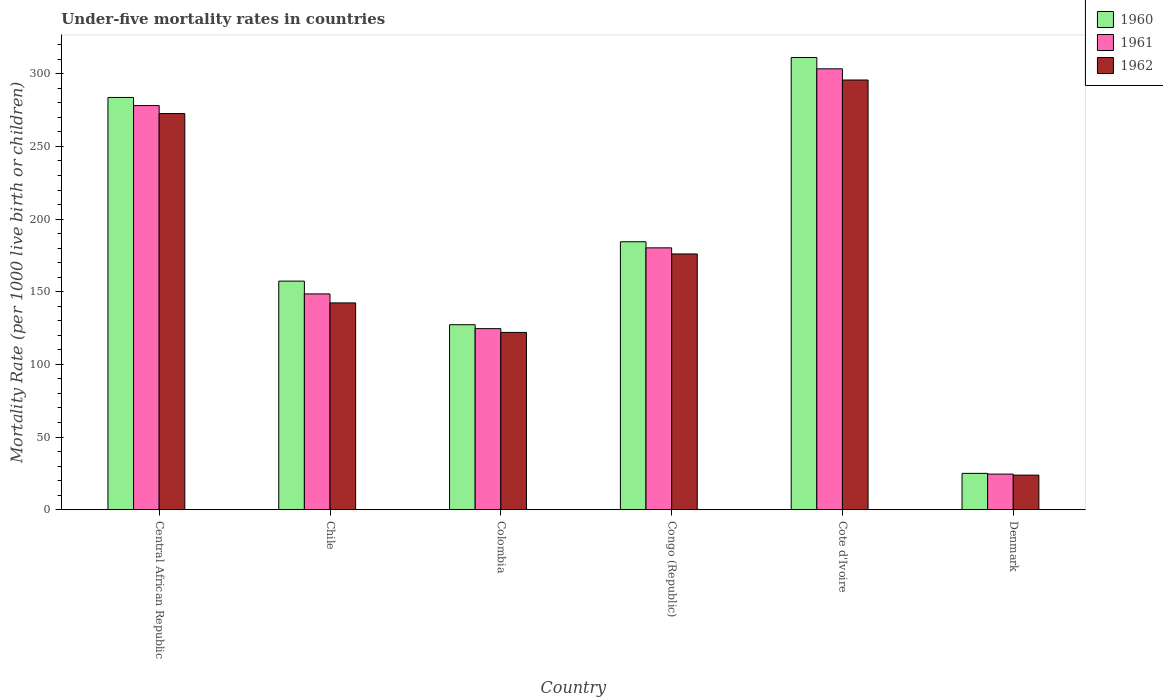How many different coloured bars are there?
Give a very brief answer. 3. How many groups of bars are there?
Your answer should be very brief. 6. Are the number of bars per tick equal to the number of legend labels?
Make the answer very short. Yes. Are the number of bars on each tick of the X-axis equal?
Give a very brief answer. Yes. How many bars are there on the 5th tick from the left?
Provide a succinct answer. 3. How many bars are there on the 6th tick from the right?
Provide a short and direct response. 3. What is the label of the 1st group of bars from the left?
Your answer should be compact. Central African Republic. In how many cases, is the number of bars for a given country not equal to the number of legend labels?
Make the answer very short. 0. What is the under-five mortality rate in 1960 in Central African Republic?
Make the answer very short. 283.7. Across all countries, what is the maximum under-five mortality rate in 1962?
Offer a terse response. 295.7. Across all countries, what is the minimum under-five mortality rate in 1961?
Make the answer very short. 24.5. In which country was the under-five mortality rate in 1961 maximum?
Provide a succinct answer. Cote d'Ivoire. What is the total under-five mortality rate in 1961 in the graph?
Your response must be concise. 1059.3. What is the difference between the under-five mortality rate in 1962 in Chile and that in Denmark?
Keep it short and to the point. 118.5. What is the difference between the under-five mortality rate in 1962 in Colombia and the under-five mortality rate in 1961 in Congo (Republic)?
Keep it short and to the point. -58.2. What is the average under-five mortality rate in 1962 per country?
Ensure brevity in your answer.  172.07. What is the difference between the under-five mortality rate of/in 1961 and under-five mortality rate of/in 1960 in Colombia?
Keep it short and to the point. -2.7. What is the ratio of the under-five mortality rate in 1962 in Chile to that in Congo (Republic)?
Provide a short and direct response. 0.81. Is the under-five mortality rate in 1962 in Chile less than that in Colombia?
Provide a succinct answer. No. Is the difference between the under-five mortality rate in 1961 in Cote d'Ivoire and Denmark greater than the difference between the under-five mortality rate in 1960 in Cote d'Ivoire and Denmark?
Your answer should be very brief. No. What is the difference between the highest and the second highest under-five mortality rate in 1961?
Keep it short and to the point. -97.9. What is the difference between the highest and the lowest under-five mortality rate in 1960?
Keep it short and to the point. 286.2. In how many countries, is the under-five mortality rate in 1960 greater than the average under-five mortality rate in 1960 taken over all countries?
Give a very brief answer. 3. Is the sum of the under-five mortality rate in 1961 in Colombia and Congo (Republic) greater than the maximum under-five mortality rate in 1962 across all countries?
Your answer should be compact. Yes. How many bars are there?
Your response must be concise. 18. How many countries are there in the graph?
Offer a very short reply. 6. Does the graph contain any zero values?
Provide a succinct answer. No. Does the graph contain grids?
Make the answer very short. No. How many legend labels are there?
Provide a short and direct response. 3. How are the legend labels stacked?
Make the answer very short. Vertical. What is the title of the graph?
Provide a succinct answer. Under-five mortality rates in countries. What is the label or title of the Y-axis?
Your response must be concise. Mortality Rate (per 1000 live birth or children). What is the Mortality Rate (per 1000 live birth or children) of 1960 in Central African Republic?
Offer a terse response. 283.7. What is the Mortality Rate (per 1000 live birth or children) in 1961 in Central African Republic?
Make the answer very short. 278.1. What is the Mortality Rate (per 1000 live birth or children) of 1962 in Central African Republic?
Offer a very short reply. 272.6. What is the Mortality Rate (per 1000 live birth or children) in 1960 in Chile?
Your response must be concise. 157.3. What is the Mortality Rate (per 1000 live birth or children) in 1961 in Chile?
Keep it short and to the point. 148.5. What is the Mortality Rate (per 1000 live birth or children) of 1962 in Chile?
Offer a terse response. 142.3. What is the Mortality Rate (per 1000 live birth or children) in 1960 in Colombia?
Provide a short and direct response. 127.3. What is the Mortality Rate (per 1000 live birth or children) of 1961 in Colombia?
Provide a short and direct response. 124.6. What is the Mortality Rate (per 1000 live birth or children) of 1962 in Colombia?
Your answer should be compact. 122. What is the Mortality Rate (per 1000 live birth or children) in 1960 in Congo (Republic)?
Make the answer very short. 184.4. What is the Mortality Rate (per 1000 live birth or children) of 1961 in Congo (Republic)?
Offer a terse response. 180.2. What is the Mortality Rate (per 1000 live birth or children) of 1962 in Congo (Republic)?
Keep it short and to the point. 176. What is the Mortality Rate (per 1000 live birth or children) in 1960 in Cote d'Ivoire?
Offer a terse response. 311.2. What is the Mortality Rate (per 1000 live birth or children) in 1961 in Cote d'Ivoire?
Your response must be concise. 303.4. What is the Mortality Rate (per 1000 live birth or children) of 1962 in Cote d'Ivoire?
Provide a short and direct response. 295.7. What is the Mortality Rate (per 1000 live birth or children) of 1962 in Denmark?
Offer a very short reply. 23.8. Across all countries, what is the maximum Mortality Rate (per 1000 live birth or children) in 1960?
Your answer should be compact. 311.2. Across all countries, what is the maximum Mortality Rate (per 1000 live birth or children) of 1961?
Keep it short and to the point. 303.4. Across all countries, what is the maximum Mortality Rate (per 1000 live birth or children) of 1962?
Your answer should be compact. 295.7. Across all countries, what is the minimum Mortality Rate (per 1000 live birth or children) of 1961?
Make the answer very short. 24.5. Across all countries, what is the minimum Mortality Rate (per 1000 live birth or children) in 1962?
Offer a terse response. 23.8. What is the total Mortality Rate (per 1000 live birth or children) in 1960 in the graph?
Offer a terse response. 1088.9. What is the total Mortality Rate (per 1000 live birth or children) of 1961 in the graph?
Make the answer very short. 1059.3. What is the total Mortality Rate (per 1000 live birth or children) of 1962 in the graph?
Keep it short and to the point. 1032.4. What is the difference between the Mortality Rate (per 1000 live birth or children) of 1960 in Central African Republic and that in Chile?
Offer a very short reply. 126.4. What is the difference between the Mortality Rate (per 1000 live birth or children) in 1961 in Central African Republic and that in Chile?
Give a very brief answer. 129.6. What is the difference between the Mortality Rate (per 1000 live birth or children) of 1962 in Central African Republic and that in Chile?
Give a very brief answer. 130.3. What is the difference between the Mortality Rate (per 1000 live birth or children) in 1960 in Central African Republic and that in Colombia?
Provide a short and direct response. 156.4. What is the difference between the Mortality Rate (per 1000 live birth or children) of 1961 in Central African Republic and that in Colombia?
Keep it short and to the point. 153.5. What is the difference between the Mortality Rate (per 1000 live birth or children) in 1962 in Central African Republic and that in Colombia?
Your answer should be very brief. 150.6. What is the difference between the Mortality Rate (per 1000 live birth or children) in 1960 in Central African Republic and that in Congo (Republic)?
Provide a succinct answer. 99.3. What is the difference between the Mortality Rate (per 1000 live birth or children) of 1961 in Central African Republic and that in Congo (Republic)?
Ensure brevity in your answer.  97.9. What is the difference between the Mortality Rate (per 1000 live birth or children) in 1962 in Central African Republic and that in Congo (Republic)?
Your response must be concise. 96.6. What is the difference between the Mortality Rate (per 1000 live birth or children) of 1960 in Central African Republic and that in Cote d'Ivoire?
Provide a short and direct response. -27.5. What is the difference between the Mortality Rate (per 1000 live birth or children) in 1961 in Central African Republic and that in Cote d'Ivoire?
Offer a very short reply. -25.3. What is the difference between the Mortality Rate (per 1000 live birth or children) in 1962 in Central African Republic and that in Cote d'Ivoire?
Provide a succinct answer. -23.1. What is the difference between the Mortality Rate (per 1000 live birth or children) in 1960 in Central African Republic and that in Denmark?
Offer a very short reply. 258.7. What is the difference between the Mortality Rate (per 1000 live birth or children) of 1961 in Central African Republic and that in Denmark?
Provide a short and direct response. 253.6. What is the difference between the Mortality Rate (per 1000 live birth or children) of 1962 in Central African Republic and that in Denmark?
Keep it short and to the point. 248.8. What is the difference between the Mortality Rate (per 1000 live birth or children) in 1961 in Chile and that in Colombia?
Your answer should be very brief. 23.9. What is the difference between the Mortality Rate (per 1000 live birth or children) in 1962 in Chile and that in Colombia?
Ensure brevity in your answer.  20.3. What is the difference between the Mortality Rate (per 1000 live birth or children) in 1960 in Chile and that in Congo (Republic)?
Your answer should be very brief. -27.1. What is the difference between the Mortality Rate (per 1000 live birth or children) in 1961 in Chile and that in Congo (Republic)?
Ensure brevity in your answer.  -31.7. What is the difference between the Mortality Rate (per 1000 live birth or children) in 1962 in Chile and that in Congo (Republic)?
Make the answer very short. -33.7. What is the difference between the Mortality Rate (per 1000 live birth or children) in 1960 in Chile and that in Cote d'Ivoire?
Your response must be concise. -153.9. What is the difference between the Mortality Rate (per 1000 live birth or children) in 1961 in Chile and that in Cote d'Ivoire?
Keep it short and to the point. -154.9. What is the difference between the Mortality Rate (per 1000 live birth or children) of 1962 in Chile and that in Cote d'Ivoire?
Your answer should be compact. -153.4. What is the difference between the Mortality Rate (per 1000 live birth or children) of 1960 in Chile and that in Denmark?
Provide a short and direct response. 132.3. What is the difference between the Mortality Rate (per 1000 live birth or children) of 1961 in Chile and that in Denmark?
Your response must be concise. 124. What is the difference between the Mortality Rate (per 1000 live birth or children) of 1962 in Chile and that in Denmark?
Your response must be concise. 118.5. What is the difference between the Mortality Rate (per 1000 live birth or children) in 1960 in Colombia and that in Congo (Republic)?
Keep it short and to the point. -57.1. What is the difference between the Mortality Rate (per 1000 live birth or children) of 1961 in Colombia and that in Congo (Republic)?
Keep it short and to the point. -55.6. What is the difference between the Mortality Rate (per 1000 live birth or children) of 1962 in Colombia and that in Congo (Republic)?
Make the answer very short. -54. What is the difference between the Mortality Rate (per 1000 live birth or children) in 1960 in Colombia and that in Cote d'Ivoire?
Offer a terse response. -183.9. What is the difference between the Mortality Rate (per 1000 live birth or children) in 1961 in Colombia and that in Cote d'Ivoire?
Make the answer very short. -178.8. What is the difference between the Mortality Rate (per 1000 live birth or children) of 1962 in Colombia and that in Cote d'Ivoire?
Offer a very short reply. -173.7. What is the difference between the Mortality Rate (per 1000 live birth or children) of 1960 in Colombia and that in Denmark?
Give a very brief answer. 102.3. What is the difference between the Mortality Rate (per 1000 live birth or children) of 1961 in Colombia and that in Denmark?
Provide a succinct answer. 100.1. What is the difference between the Mortality Rate (per 1000 live birth or children) in 1962 in Colombia and that in Denmark?
Offer a very short reply. 98.2. What is the difference between the Mortality Rate (per 1000 live birth or children) of 1960 in Congo (Republic) and that in Cote d'Ivoire?
Offer a terse response. -126.8. What is the difference between the Mortality Rate (per 1000 live birth or children) of 1961 in Congo (Republic) and that in Cote d'Ivoire?
Your answer should be compact. -123.2. What is the difference between the Mortality Rate (per 1000 live birth or children) of 1962 in Congo (Republic) and that in Cote d'Ivoire?
Your response must be concise. -119.7. What is the difference between the Mortality Rate (per 1000 live birth or children) of 1960 in Congo (Republic) and that in Denmark?
Your response must be concise. 159.4. What is the difference between the Mortality Rate (per 1000 live birth or children) in 1961 in Congo (Republic) and that in Denmark?
Offer a very short reply. 155.7. What is the difference between the Mortality Rate (per 1000 live birth or children) in 1962 in Congo (Republic) and that in Denmark?
Your answer should be compact. 152.2. What is the difference between the Mortality Rate (per 1000 live birth or children) of 1960 in Cote d'Ivoire and that in Denmark?
Provide a short and direct response. 286.2. What is the difference between the Mortality Rate (per 1000 live birth or children) of 1961 in Cote d'Ivoire and that in Denmark?
Ensure brevity in your answer.  278.9. What is the difference between the Mortality Rate (per 1000 live birth or children) in 1962 in Cote d'Ivoire and that in Denmark?
Ensure brevity in your answer.  271.9. What is the difference between the Mortality Rate (per 1000 live birth or children) of 1960 in Central African Republic and the Mortality Rate (per 1000 live birth or children) of 1961 in Chile?
Give a very brief answer. 135.2. What is the difference between the Mortality Rate (per 1000 live birth or children) in 1960 in Central African Republic and the Mortality Rate (per 1000 live birth or children) in 1962 in Chile?
Your answer should be compact. 141.4. What is the difference between the Mortality Rate (per 1000 live birth or children) in 1961 in Central African Republic and the Mortality Rate (per 1000 live birth or children) in 1962 in Chile?
Make the answer very short. 135.8. What is the difference between the Mortality Rate (per 1000 live birth or children) in 1960 in Central African Republic and the Mortality Rate (per 1000 live birth or children) in 1961 in Colombia?
Keep it short and to the point. 159.1. What is the difference between the Mortality Rate (per 1000 live birth or children) in 1960 in Central African Republic and the Mortality Rate (per 1000 live birth or children) in 1962 in Colombia?
Offer a terse response. 161.7. What is the difference between the Mortality Rate (per 1000 live birth or children) in 1961 in Central African Republic and the Mortality Rate (per 1000 live birth or children) in 1962 in Colombia?
Provide a short and direct response. 156.1. What is the difference between the Mortality Rate (per 1000 live birth or children) in 1960 in Central African Republic and the Mortality Rate (per 1000 live birth or children) in 1961 in Congo (Republic)?
Provide a succinct answer. 103.5. What is the difference between the Mortality Rate (per 1000 live birth or children) of 1960 in Central African Republic and the Mortality Rate (per 1000 live birth or children) of 1962 in Congo (Republic)?
Offer a very short reply. 107.7. What is the difference between the Mortality Rate (per 1000 live birth or children) in 1961 in Central African Republic and the Mortality Rate (per 1000 live birth or children) in 1962 in Congo (Republic)?
Your answer should be compact. 102.1. What is the difference between the Mortality Rate (per 1000 live birth or children) of 1960 in Central African Republic and the Mortality Rate (per 1000 live birth or children) of 1961 in Cote d'Ivoire?
Keep it short and to the point. -19.7. What is the difference between the Mortality Rate (per 1000 live birth or children) of 1961 in Central African Republic and the Mortality Rate (per 1000 live birth or children) of 1962 in Cote d'Ivoire?
Your answer should be very brief. -17.6. What is the difference between the Mortality Rate (per 1000 live birth or children) of 1960 in Central African Republic and the Mortality Rate (per 1000 live birth or children) of 1961 in Denmark?
Keep it short and to the point. 259.2. What is the difference between the Mortality Rate (per 1000 live birth or children) in 1960 in Central African Republic and the Mortality Rate (per 1000 live birth or children) in 1962 in Denmark?
Your answer should be compact. 259.9. What is the difference between the Mortality Rate (per 1000 live birth or children) of 1961 in Central African Republic and the Mortality Rate (per 1000 live birth or children) of 1962 in Denmark?
Ensure brevity in your answer.  254.3. What is the difference between the Mortality Rate (per 1000 live birth or children) of 1960 in Chile and the Mortality Rate (per 1000 live birth or children) of 1961 in Colombia?
Your answer should be very brief. 32.7. What is the difference between the Mortality Rate (per 1000 live birth or children) of 1960 in Chile and the Mortality Rate (per 1000 live birth or children) of 1962 in Colombia?
Offer a terse response. 35.3. What is the difference between the Mortality Rate (per 1000 live birth or children) in 1960 in Chile and the Mortality Rate (per 1000 live birth or children) in 1961 in Congo (Republic)?
Give a very brief answer. -22.9. What is the difference between the Mortality Rate (per 1000 live birth or children) in 1960 in Chile and the Mortality Rate (per 1000 live birth or children) in 1962 in Congo (Republic)?
Offer a terse response. -18.7. What is the difference between the Mortality Rate (per 1000 live birth or children) of 1961 in Chile and the Mortality Rate (per 1000 live birth or children) of 1962 in Congo (Republic)?
Offer a very short reply. -27.5. What is the difference between the Mortality Rate (per 1000 live birth or children) of 1960 in Chile and the Mortality Rate (per 1000 live birth or children) of 1961 in Cote d'Ivoire?
Give a very brief answer. -146.1. What is the difference between the Mortality Rate (per 1000 live birth or children) of 1960 in Chile and the Mortality Rate (per 1000 live birth or children) of 1962 in Cote d'Ivoire?
Offer a terse response. -138.4. What is the difference between the Mortality Rate (per 1000 live birth or children) of 1961 in Chile and the Mortality Rate (per 1000 live birth or children) of 1962 in Cote d'Ivoire?
Your answer should be very brief. -147.2. What is the difference between the Mortality Rate (per 1000 live birth or children) in 1960 in Chile and the Mortality Rate (per 1000 live birth or children) in 1961 in Denmark?
Your answer should be compact. 132.8. What is the difference between the Mortality Rate (per 1000 live birth or children) of 1960 in Chile and the Mortality Rate (per 1000 live birth or children) of 1962 in Denmark?
Ensure brevity in your answer.  133.5. What is the difference between the Mortality Rate (per 1000 live birth or children) of 1961 in Chile and the Mortality Rate (per 1000 live birth or children) of 1962 in Denmark?
Your response must be concise. 124.7. What is the difference between the Mortality Rate (per 1000 live birth or children) in 1960 in Colombia and the Mortality Rate (per 1000 live birth or children) in 1961 in Congo (Republic)?
Ensure brevity in your answer.  -52.9. What is the difference between the Mortality Rate (per 1000 live birth or children) in 1960 in Colombia and the Mortality Rate (per 1000 live birth or children) in 1962 in Congo (Republic)?
Provide a succinct answer. -48.7. What is the difference between the Mortality Rate (per 1000 live birth or children) in 1961 in Colombia and the Mortality Rate (per 1000 live birth or children) in 1962 in Congo (Republic)?
Your answer should be compact. -51.4. What is the difference between the Mortality Rate (per 1000 live birth or children) of 1960 in Colombia and the Mortality Rate (per 1000 live birth or children) of 1961 in Cote d'Ivoire?
Make the answer very short. -176.1. What is the difference between the Mortality Rate (per 1000 live birth or children) of 1960 in Colombia and the Mortality Rate (per 1000 live birth or children) of 1962 in Cote d'Ivoire?
Provide a succinct answer. -168.4. What is the difference between the Mortality Rate (per 1000 live birth or children) of 1961 in Colombia and the Mortality Rate (per 1000 live birth or children) of 1962 in Cote d'Ivoire?
Offer a terse response. -171.1. What is the difference between the Mortality Rate (per 1000 live birth or children) in 1960 in Colombia and the Mortality Rate (per 1000 live birth or children) in 1961 in Denmark?
Your response must be concise. 102.8. What is the difference between the Mortality Rate (per 1000 live birth or children) in 1960 in Colombia and the Mortality Rate (per 1000 live birth or children) in 1962 in Denmark?
Your response must be concise. 103.5. What is the difference between the Mortality Rate (per 1000 live birth or children) of 1961 in Colombia and the Mortality Rate (per 1000 live birth or children) of 1962 in Denmark?
Offer a very short reply. 100.8. What is the difference between the Mortality Rate (per 1000 live birth or children) of 1960 in Congo (Republic) and the Mortality Rate (per 1000 live birth or children) of 1961 in Cote d'Ivoire?
Provide a short and direct response. -119. What is the difference between the Mortality Rate (per 1000 live birth or children) of 1960 in Congo (Republic) and the Mortality Rate (per 1000 live birth or children) of 1962 in Cote d'Ivoire?
Your answer should be compact. -111.3. What is the difference between the Mortality Rate (per 1000 live birth or children) in 1961 in Congo (Republic) and the Mortality Rate (per 1000 live birth or children) in 1962 in Cote d'Ivoire?
Provide a short and direct response. -115.5. What is the difference between the Mortality Rate (per 1000 live birth or children) in 1960 in Congo (Republic) and the Mortality Rate (per 1000 live birth or children) in 1961 in Denmark?
Offer a very short reply. 159.9. What is the difference between the Mortality Rate (per 1000 live birth or children) in 1960 in Congo (Republic) and the Mortality Rate (per 1000 live birth or children) in 1962 in Denmark?
Provide a succinct answer. 160.6. What is the difference between the Mortality Rate (per 1000 live birth or children) of 1961 in Congo (Republic) and the Mortality Rate (per 1000 live birth or children) of 1962 in Denmark?
Ensure brevity in your answer.  156.4. What is the difference between the Mortality Rate (per 1000 live birth or children) in 1960 in Cote d'Ivoire and the Mortality Rate (per 1000 live birth or children) in 1961 in Denmark?
Offer a terse response. 286.7. What is the difference between the Mortality Rate (per 1000 live birth or children) of 1960 in Cote d'Ivoire and the Mortality Rate (per 1000 live birth or children) of 1962 in Denmark?
Keep it short and to the point. 287.4. What is the difference between the Mortality Rate (per 1000 live birth or children) of 1961 in Cote d'Ivoire and the Mortality Rate (per 1000 live birth or children) of 1962 in Denmark?
Give a very brief answer. 279.6. What is the average Mortality Rate (per 1000 live birth or children) of 1960 per country?
Offer a terse response. 181.48. What is the average Mortality Rate (per 1000 live birth or children) in 1961 per country?
Keep it short and to the point. 176.55. What is the average Mortality Rate (per 1000 live birth or children) in 1962 per country?
Provide a short and direct response. 172.07. What is the difference between the Mortality Rate (per 1000 live birth or children) of 1960 and Mortality Rate (per 1000 live birth or children) of 1961 in Central African Republic?
Ensure brevity in your answer.  5.6. What is the difference between the Mortality Rate (per 1000 live birth or children) in 1961 and Mortality Rate (per 1000 live birth or children) in 1962 in Central African Republic?
Provide a short and direct response. 5.5. What is the difference between the Mortality Rate (per 1000 live birth or children) in 1960 and Mortality Rate (per 1000 live birth or children) in 1962 in Chile?
Offer a very short reply. 15. What is the difference between the Mortality Rate (per 1000 live birth or children) in 1960 and Mortality Rate (per 1000 live birth or children) in 1962 in Colombia?
Give a very brief answer. 5.3. What is the difference between the Mortality Rate (per 1000 live birth or children) in 1960 and Mortality Rate (per 1000 live birth or children) in 1961 in Cote d'Ivoire?
Your answer should be compact. 7.8. What is the difference between the Mortality Rate (per 1000 live birth or children) of 1960 and Mortality Rate (per 1000 live birth or children) of 1961 in Denmark?
Offer a terse response. 0.5. What is the ratio of the Mortality Rate (per 1000 live birth or children) in 1960 in Central African Republic to that in Chile?
Offer a very short reply. 1.8. What is the ratio of the Mortality Rate (per 1000 live birth or children) in 1961 in Central African Republic to that in Chile?
Offer a very short reply. 1.87. What is the ratio of the Mortality Rate (per 1000 live birth or children) of 1962 in Central African Republic to that in Chile?
Your answer should be compact. 1.92. What is the ratio of the Mortality Rate (per 1000 live birth or children) of 1960 in Central African Republic to that in Colombia?
Your answer should be very brief. 2.23. What is the ratio of the Mortality Rate (per 1000 live birth or children) of 1961 in Central African Republic to that in Colombia?
Ensure brevity in your answer.  2.23. What is the ratio of the Mortality Rate (per 1000 live birth or children) in 1962 in Central African Republic to that in Colombia?
Ensure brevity in your answer.  2.23. What is the ratio of the Mortality Rate (per 1000 live birth or children) of 1960 in Central African Republic to that in Congo (Republic)?
Offer a very short reply. 1.54. What is the ratio of the Mortality Rate (per 1000 live birth or children) in 1961 in Central African Republic to that in Congo (Republic)?
Offer a terse response. 1.54. What is the ratio of the Mortality Rate (per 1000 live birth or children) of 1962 in Central African Republic to that in Congo (Republic)?
Keep it short and to the point. 1.55. What is the ratio of the Mortality Rate (per 1000 live birth or children) of 1960 in Central African Republic to that in Cote d'Ivoire?
Keep it short and to the point. 0.91. What is the ratio of the Mortality Rate (per 1000 live birth or children) in 1961 in Central African Republic to that in Cote d'Ivoire?
Your answer should be very brief. 0.92. What is the ratio of the Mortality Rate (per 1000 live birth or children) of 1962 in Central African Republic to that in Cote d'Ivoire?
Keep it short and to the point. 0.92. What is the ratio of the Mortality Rate (per 1000 live birth or children) of 1960 in Central African Republic to that in Denmark?
Your answer should be compact. 11.35. What is the ratio of the Mortality Rate (per 1000 live birth or children) of 1961 in Central African Republic to that in Denmark?
Provide a short and direct response. 11.35. What is the ratio of the Mortality Rate (per 1000 live birth or children) of 1962 in Central African Republic to that in Denmark?
Keep it short and to the point. 11.45. What is the ratio of the Mortality Rate (per 1000 live birth or children) of 1960 in Chile to that in Colombia?
Give a very brief answer. 1.24. What is the ratio of the Mortality Rate (per 1000 live birth or children) in 1961 in Chile to that in Colombia?
Offer a terse response. 1.19. What is the ratio of the Mortality Rate (per 1000 live birth or children) of 1962 in Chile to that in Colombia?
Keep it short and to the point. 1.17. What is the ratio of the Mortality Rate (per 1000 live birth or children) in 1960 in Chile to that in Congo (Republic)?
Your answer should be compact. 0.85. What is the ratio of the Mortality Rate (per 1000 live birth or children) of 1961 in Chile to that in Congo (Republic)?
Your answer should be compact. 0.82. What is the ratio of the Mortality Rate (per 1000 live birth or children) of 1962 in Chile to that in Congo (Republic)?
Ensure brevity in your answer.  0.81. What is the ratio of the Mortality Rate (per 1000 live birth or children) in 1960 in Chile to that in Cote d'Ivoire?
Make the answer very short. 0.51. What is the ratio of the Mortality Rate (per 1000 live birth or children) of 1961 in Chile to that in Cote d'Ivoire?
Offer a terse response. 0.49. What is the ratio of the Mortality Rate (per 1000 live birth or children) in 1962 in Chile to that in Cote d'Ivoire?
Ensure brevity in your answer.  0.48. What is the ratio of the Mortality Rate (per 1000 live birth or children) in 1960 in Chile to that in Denmark?
Give a very brief answer. 6.29. What is the ratio of the Mortality Rate (per 1000 live birth or children) of 1961 in Chile to that in Denmark?
Offer a very short reply. 6.06. What is the ratio of the Mortality Rate (per 1000 live birth or children) of 1962 in Chile to that in Denmark?
Your answer should be very brief. 5.98. What is the ratio of the Mortality Rate (per 1000 live birth or children) in 1960 in Colombia to that in Congo (Republic)?
Offer a very short reply. 0.69. What is the ratio of the Mortality Rate (per 1000 live birth or children) in 1961 in Colombia to that in Congo (Republic)?
Provide a short and direct response. 0.69. What is the ratio of the Mortality Rate (per 1000 live birth or children) of 1962 in Colombia to that in Congo (Republic)?
Give a very brief answer. 0.69. What is the ratio of the Mortality Rate (per 1000 live birth or children) of 1960 in Colombia to that in Cote d'Ivoire?
Provide a short and direct response. 0.41. What is the ratio of the Mortality Rate (per 1000 live birth or children) of 1961 in Colombia to that in Cote d'Ivoire?
Your answer should be very brief. 0.41. What is the ratio of the Mortality Rate (per 1000 live birth or children) in 1962 in Colombia to that in Cote d'Ivoire?
Offer a very short reply. 0.41. What is the ratio of the Mortality Rate (per 1000 live birth or children) of 1960 in Colombia to that in Denmark?
Offer a terse response. 5.09. What is the ratio of the Mortality Rate (per 1000 live birth or children) of 1961 in Colombia to that in Denmark?
Your answer should be compact. 5.09. What is the ratio of the Mortality Rate (per 1000 live birth or children) of 1962 in Colombia to that in Denmark?
Provide a succinct answer. 5.13. What is the ratio of the Mortality Rate (per 1000 live birth or children) of 1960 in Congo (Republic) to that in Cote d'Ivoire?
Your answer should be very brief. 0.59. What is the ratio of the Mortality Rate (per 1000 live birth or children) in 1961 in Congo (Republic) to that in Cote d'Ivoire?
Your answer should be compact. 0.59. What is the ratio of the Mortality Rate (per 1000 live birth or children) of 1962 in Congo (Republic) to that in Cote d'Ivoire?
Offer a very short reply. 0.6. What is the ratio of the Mortality Rate (per 1000 live birth or children) of 1960 in Congo (Republic) to that in Denmark?
Your answer should be compact. 7.38. What is the ratio of the Mortality Rate (per 1000 live birth or children) of 1961 in Congo (Republic) to that in Denmark?
Your answer should be very brief. 7.36. What is the ratio of the Mortality Rate (per 1000 live birth or children) in 1962 in Congo (Republic) to that in Denmark?
Your response must be concise. 7.39. What is the ratio of the Mortality Rate (per 1000 live birth or children) in 1960 in Cote d'Ivoire to that in Denmark?
Ensure brevity in your answer.  12.45. What is the ratio of the Mortality Rate (per 1000 live birth or children) of 1961 in Cote d'Ivoire to that in Denmark?
Keep it short and to the point. 12.38. What is the ratio of the Mortality Rate (per 1000 live birth or children) in 1962 in Cote d'Ivoire to that in Denmark?
Make the answer very short. 12.42. What is the difference between the highest and the second highest Mortality Rate (per 1000 live birth or children) in 1960?
Your answer should be compact. 27.5. What is the difference between the highest and the second highest Mortality Rate (per 1000 live birth or children) in 1961?
Your response must be concise. 25.3. What is the difference between the highest and the second highest Mortality Rate (per 1000 live birth or children) in 1962?
Make the answer very short. 23.1. What is the difference between the highest and the lowest Mortality Rate (per 1000 live birth or children) of 1960?
Your answer should be very brief. 286.2. What is the difference between the highest and the lowest Mortality Rate (per 1000 live birth or children) in 1961?
Provide a succinct answer. 278.9. What is the difference between the highest and the lowest Mortality Rate (per 1000 live birth or children) in 1962?
Make the answer very short. 271.9. 